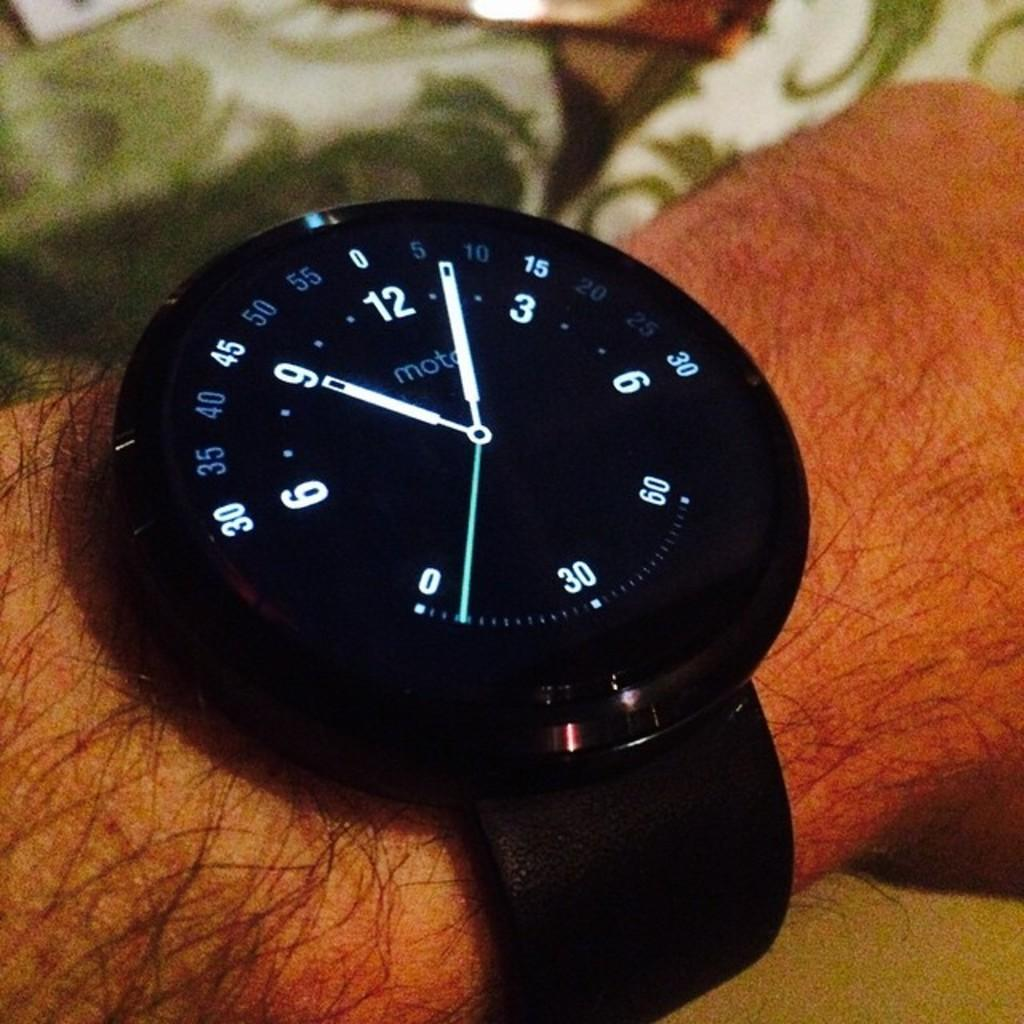<image>
Describe the image concisely. A black watch reads about 9:05 and is on a wrist. 